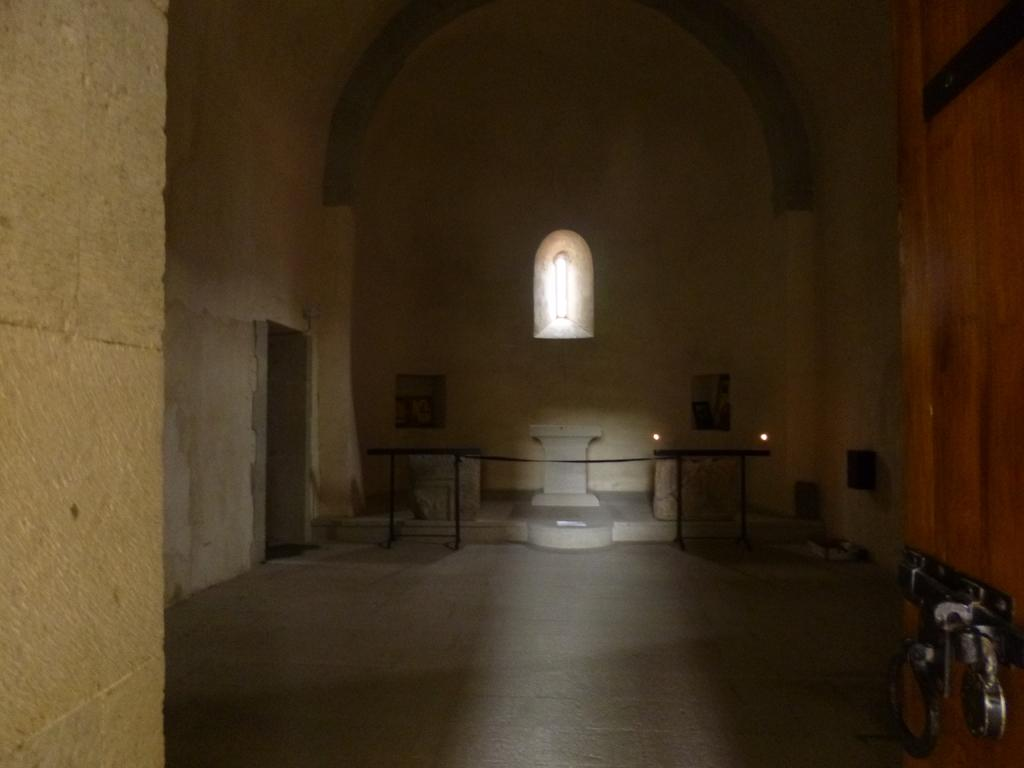Where was the image taken? The image was taken inside a room. What can be seen behind the fence in the image? There is a pillar behind the fence. What is visible in the wall of the room? There is a window in the wall. What is the wall with the window connected to? The wall with the window has a door. Where is the second door located in the image? There is a door on the right side of the image. What feature does the second door have? The door on the right side has a lock. Reasoning: Let's think step by step by step in order to produce the conversation. We start by identifying the location of the image, which is inside a room. Then, we describe the main objects and features in the room, such as the pillar, window, and doors. Each question is designed to elicit a specific detail about the image that is known from the provided facts. Absurd Question/Answer: Can you see a person biting into a sandwich in the image? No, there is no person or sandwich present in the image. Is there a person biting into a sandwich in the image? No, there is no person or sandwich present in the image. 